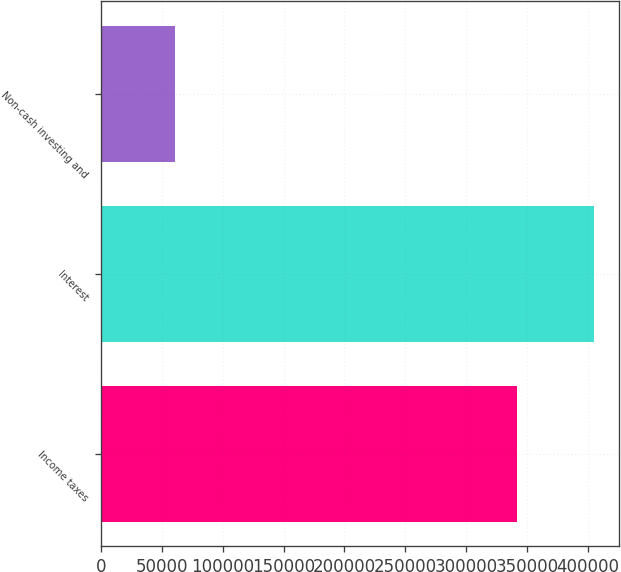<chart> <loc_0><loc_0><loc_500><loc_500><bar_chart><fcel>Income taxes<fcel>Interest<fcel>Non-cash investing and<nl><fcel>341426<fcel>405030<fcel>60920<nl></chart> 